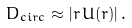Convert formula to latex. <formula><loc_0><loc_0><loc_500><loc_500>D _ { c i r c } \approx | r \, U ( r ) | \, .</formula> 